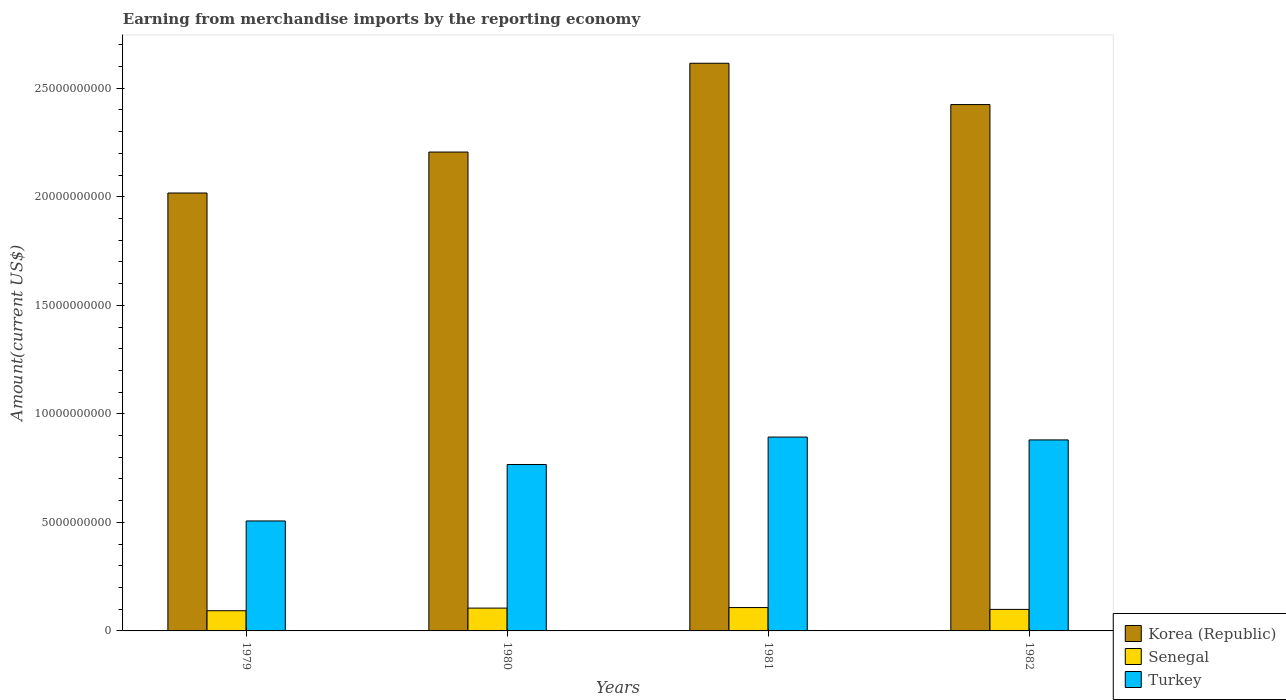Are the number of bars on each tick of the X-axis equal?
Your answer should be very brief. Yes. How many bars are there on the 1st tick from the left?
Provide a short and direct response. 3. What is the label of the 3rd group of bars from the left?
Your answer should be compact. 1981. What is the amount earned from merchandise imports in Turkey in 1982?
Offer a very short reply. 8.80e+09. Across all years, what is the maximum amount earned from merchandise imports in Korea (Republic)?
Your answer should be very brief. 2.62e+1. Across all years, what is the minimum amount earned from merchandise imports in Turkey?
Keep it short and to the point. 5.07e+09. In which year was the amount earned from merchandise imports in Korea (Republic) minimum?
Offer a terse response. 1979. What is the total amount earned from merchandise imports in Korea (Republic) in the graph?
Your response must be concise. 9.26e+1. What is the difference between the amount earned from merchandise imports in Turkey in 1980 and that in 1981?
Give a very brief answer. -1.26e+09. What is the difference between the amount earned from merchandise imports in Senegal in 1981 and the amount earned from merchandise imports in Korea (Republic) in 1980?
Provide a short and direct response. -2.10e+1. What is the average amount earned from merchandise imports in Korea (Republic) per year?
Make the answer very short. 2.32e+1. In the year 1980, what is the difference between the amount earned from merchandise imports in Turkey and amount earned from merchandise imports in Senegal?
Provide a succinct answer. 6.62e+09. In how many years, is the amount earned from merchandise imports in Turkey greater than 23000000000 US$?
Make the answer very short. 0. What is the ratio of the amount earned from merchandise imports in Turkey in 1981 to that in 1982?
Your answer should be compact. 1.01. Is the amount earned from merchandise imports in Senegal in 1980 less than that in 1982?
Offer a very short reply. No. Is the difference between the amount earned from merchandise imports in Turkey in 1979 and 1980 greater than the difference between the amount earned from merchandise imports in Senegal in 1979 and 1980?
Ensure brevity in your answer.  No. What is the difference between the highest and the second highest amount earned from merchandise imports in Turkey?
Provide a short and direct response. 1.31e+08. What is the difference between the highest and the lowest amount earned from merchandise imports in Turkey?
Ensure brevity in your answer.  3.87e+09. In how many years, is the amount earned from merchandise imports in Turkey greater than the average amount earned from merchandise imports in Turkey taken over all years?
Your answer should be compact. 3. What does the 3rd bar from the left in 1982 represents?
Your response must be concise. Turkey. What does the 2nd bar from the right in 1980 represents?
Offer a very short reply. Senegal. How many bars are there?
Provide a short and direct response. 12. How many years are there in the graph?
Offer a very short reply. 4. What is the difference between two consecutive major ticks on the Y-axis?
Offer a very short reply. 5.00e+09. Does the graph contain any zero values?
Make the answer very short. No. Does the graph contain grids?
Give a very brief answer. No. Where does the legend appear in the graph?
Make the answer very short. Bottom right. What is the title of the graph?
Keep it short and to the point. Earning from merchandise imports by the reporting economy. What is the label or title of the X-axis?
Offer a terse response. Years. What is the label or title of the Y-axis?
Give a very brief answer. Amount(current US$). What is the Amount(current US$) in Korea (Republic) in 1979?
Provide a succinct answer. 2.02e+1. What is the Amount(current US$) of Senegal in 1979?
Offer a terse response. 9.31e+08. What is the Amount(current US$) in Turkey in 1979?
Your answer should be compact. 5.07e+09. What is the Amount(current US$) of Korea (Republic) in 1980?
Provide a short and direct response. 2.21e+1. What is the Amount(current US$) in Senegal in 1980?
Offer a very short reply. 1.05e+09. What is the Amount(current US$) in Turkey in 1980?
Offer a terse response. 7.67e+09. What is the Amount(current US$) in Korea (Republic) in 1981?
Keep it short and to the point. 2.62e+1. What is the Amount(current US$) of Senegal in 1981?
Offer a very short reply. 1.08e+09. What is the Amount(current US$) of Turkey in 1981?
Offer a very short reply. 8.93e+09. What is the Amount(current US$) in Korea (Republic) in 1982?
Ensure brevity in your answer.  2.43e+1. What is the Amount(current US$) in Senegal in 1982?
Your answer should be compact. 9.92e+08. What is the Amount(current US$) of Turkey in 1982?
Provide a succinct answer. 8.80e+09. Across all years, what is the maximum Amount(current US$) in Korea (Republic)?
Give a very brief answer. 2.62e+1. Across all years, what is the maximum Amount(current US$) of Senegal?
Offer a very short reply. 1.08e+09. Across all years, what is the maximum Amount(current US$) of Turkey?
Offer a very short reply. 8.93e+09. Across all years, what is the minimum Amount(current US$) in Korea (Republic)?
Offer a very short reply. 2.02e+1. Across all years, what is the minimum Amount(current US$) of Senegal?
Offer a very short reply. 9.31e+08. Across all years, what is the minimum Amount(current US$) in Turkey?
Your response must be concise. 5.07e+09. What is the total Amount(current US$) in Korea (Republic) in the graph?
Your answer should be very brief. 9.26e+1. What is the total Amount(current US$) of Senegal in the graph?
Provide a succinct answer. 4.05e+09. What is the total Amount(current US$) of Turkey in the graph?
Offer a terse response. 3.05e+1. What is the difference between the Amount(current US$) of Korea (Republic) in 1979 and that in 1980?
Ensure brevity in your answer.  -1.89e+09. What is the difference between the Amount(current US$) in Senegal in 1979 and that in 1980?
Provide a short and direct response. -1.21e+08. What is the difference between the Amount(current US$) of Turkey in 1979 and that in 1980?
Give a very brief answer. -2.60e+09. What is the difference between the Amount(current US$) in Korea (Republic) in 1979 and that in 1981?
Provide a short and direct response. -5.98e+09. What is the difference between the Amount(current US$) of Senegal in 1979 and that in 1981?
Keep it short and to the point. -1.45e+08. What is the difference between the Amount(current US$) in Turkey in 1979 and that in 1981?
Give a very brief answer. -3.87e+09. What is the difference between the Amount(current US$) of Korea (Republic) in 1979 and that in 1982?
Make the answer very short. -4.07e+09. What is the difference between the Amount(current US$) of Senegal in 1979 and that in 1982?
Offer a terse response. -6.11e+07. What is the difference between the Amount(current US$) of Turkey in 1979 and that in 1982?
Make the answer very short. -3.73e+09. What is the difference between the Amount(current US$) of Korea (Republic) in 1980 and that in 1981?
Keep it short and to the point. -4.09e+09. What is the difference between the Amount(current US$) in Senegal in 1980 and that in 1981?
Offer a terse response. -2.41e+07. What is the difference between the Amount(current US$) of Turkey in 1980 and that in 1981?
Offer a terse response. -1.26e+09. What is the difference between the Amount(current US$) of Korea (Republic) in 1980 and that in 1982?
Offer a very short reply. -2.19e+09. What is the difference between the Amount(current US$) in Senegal in 1980 and that in 1982?
Provide a succinct answer. 5.99e+07. What is the difference between the Amount(current US$) of Turkey in 1980 and that in 1982?
Offer a very short reply. -1.13e+09. What is the difference between the Amount(current US$) of Korea (Republic) in 1981 and that in 1982?
Provide a short and direct response. 1.90e+09. What is the difference between the Amount(current US$) of Senegal in 1981 and that in 1982?
Your answer should be very brief. 8.40e+07. What is the difference between the Amount(current US$) in Turkey in 1981 and that in 1982?
Your answer should be very brief. 1.31e+08. What is the difference between the Amount(current US$) in Korea (Republic) in 1979 and the Amount(current US$) in Senegal in 1980?
Make the answer very short. 1.91e+1. What is the difference between the Amount(current US$) of Korea (Republic) in 1979 and the Amount(current US$) of Turkey in 1980?
Ensure brevity in your answer.  1.25e+1. What is the difference between the Amount(current US$) in Senegal in 1979 and the Amount(current US$) in Turkey in 1980?
Offer a terse response. -6.74e+09. What is the difference between the Amount(current US$) in Korea (Republic) in 1979 and the Amount(current US$) in Senegal in 1981?
Provide a succinct answer. 1.91e+1. What is the difference between the Amount(current US$) in Korea (Republic) in 1979 and the Amount(current US$) in Turkey in 1981?
Provide a succinct answer. 1.12e+1. What is the difference between the Amount(current US$) of Senegal in 1979 and the Amount(current US$) of Turkey in 1981?
Your response must be concise. -8.00e+09. What is the difference between the Amount(current US$) of Korea (Republic) in 1979 and the Amount(current US$) of Senegal in 1982?
Your answer should be compact. 1.92e+1. What is the difference between the Amount(current US$) of Korea (Republic) in 1979 and the Amount(current US$) of Turkey in 1982?
Your response must be concise. 1.14e+1. What is the difference between the Amount(current US$) in Senegal in 1979 and the Amount(current US$) in Turkey in 1982?
Offer a very short reply. -7.87e+09. What is the difference between the Amount(current US$) of Korea (Republic) in 1980 and the Amount(current US$) of Senegal in 1981?
Your response must be concise. 2.10e+1. What is the difference between the Amount(current US$) of Korea (Republic) in 1980 and the Amount(current US$) of Turkey in 1981?
Keep it short and to the point. 1.31e+1. What is the difference between the Amount(current US$) of Senegal in 1980 and the Amount(current US$) of Turkey in 1981?
Your response must be concise. -7.88e+09. What is the difference between the Amount(current US$) of Korea (Republic) in 1980 and the Amount(current US$) of Senegal in 1982?
Make the answer very short. 2.11e+1. What is the difference between the Amount(current US$) of Korea (Republic) in 1980 and the Amount(current US$) of Turkey in 1982?
Your response must be concise. 1.33e+1. What is the difference between the Amount(current US$) of Senegal in 1980 and the Amount(current US$) of Turkey in 1982?
Your response must be concise. -7.75e+09. What is the difference between the Amount(current US$) of Korea (Republic) in 1981 and the Amount(current US$) of Senegal in 1982?
Keep it short and to the point. 2.52e+1. What is the difference between the Amount(current US$) in Korea (Republic) in 1981 and the Amount(current US$) in Turkey in 1982?
Your answer should be compact. 1.74e+1. What is the difference between the Amount(current US$) in Senegal in 1981 and the Amount(current US$) in Turkey in 1982?
Provide a succinct answer. -7.72e+09. What is the average Amount(current US$) of Korea (Republic) per year?
Offer a very short reply. 2.32e+1. What is the average Amount(current US$) in Senegal per year?
Make the answer very short. 1.01e+09. What is the average Amount(current US$) in Turkey per year?
Provide a short and direct response. 7.62e+09. In the year 1979, what is the difference between the Amount(current US$) in Korea (Republic) and Amount(current US$) in Senegal?
Keep it short and to the point. 1.92e+1. In the year 1979, what is the difference between the Amount(current US$) in Korea (Republic) and Amount(current US$) in Turkey?
Provide a succinct answer. 1.51e+1. In the year 1979, what is the difference between the Amount(current US$) in Senegal and Amount(current US$) in Turkey?
Your answer should be very brief. -4.14e+09. In the year 1980, what is the difference between the Amount(current US$) of Korea (Republic) and Amount(current US$) of Senegal?
Make the answer very short. 2.10e+1. In the year 1980, what is the difference between the Amount(current US$) in Korea (Republic) and Amount(current US$) in Turkey?
Give a very brief answer. 1.44e+1. In the year 1980, what is the difference between the Amount(current US$) in Senegal and Amount(current US$) in Turkey?
Provide a short and direct response. -6.62e+09. In the year 1981, what is the difference between the Amount(current US$) of Korea (Republic) and Amount(current US$) of Senegal?
Your answer should be very brief. 2.51e+1. In the year 1981, what is the difference between the Amount(current US$) of Korea (Republic) and Amount(current US$) of Turkey?
Give a very brief answer. 1.72e+1. In the year 1981, what is the difference between the Amount(current US$) in Senegal and Amount(current US$) in Turkey?
Ensure brevity in your answer.  -7.86e+09. In the year 1982, what is the difference between the Amount(current US$) in Korea (Republic) and Amount(current US$) in Senegal?
Keep it short and to the point. 2.33e+1. In the year 1982, what is the difference between the Amount(current US$) of Korea (Republic) and Amount(current US$) of Turkey?
Ensure brevity in your answer.  1.54e+1. In the year 1982, what is the difference between the Amount(current US$) of Senegal and Amount(current US$) of Turkey?
Provide a short and direct response. -7.81e+09. What is the ratio of the Amount(current US$) in Korea (Republic) in 1979 to that in 1980?
Your answer should be very brief. 0.91. What is the ratio of the Amount(current US$) of Senegal in 1979 to that in 1980?
Ensure brevity in your answer.  0.89. What is the ratio of the Amount(current US$) of Turkey in 1979 to that in 1980?
Your response must be concise. 0.66. What is the ratio of the Amount(current US$) in Korea (Republic) in 1979 to that in 1981?
Give a very brief answer. 0.77. What is the ratio of the Amount(current US$) of Senegal in 1979 to that in 1981?
Keep it short and to the point. 0.87. What is the ratio of the Amount(current US$) in Turkey in 1979 to that in 1981?
Your response must be concise. 0.57. What is the ratio of the Amount(current US$) in Korea (Republic) in 1979 to that in 1982?
Keep it short and to the point. 0.83. What is the ratio of the Amount(current US$) of Senegal in 1979 to that in 1982?
Make the answer very short. 0.94. What is the ratio of the Amount(current US$) in Turkey in 1979 to that in 1982?
Your answer should be compact. 0.58. What is the ratio of the Amount(current US$) in Korea (Republic) in 1980 to that in 1981?
Your response must be concise. 0.84. What is the ratio of the Amount(current US$) in Senegal in 1980 to that in 1981?
Provide a short and direct response. 0.98. What is the ratio of the Amount(current US$) of Turkey in 1980 to that in 1981?
Give a very brief answer. 0.86. What is the ratio of the Amount(current US$) of Korea (Republic) in 1980 to that in 1982?
Your response must be concise. 0.91. What is the ratio of the Amount(current US$) of Senegal in 1980 to that in 1982?
Your response must be concise. 1.06. What is the ratio of the Amount(current US$) in Turkey in 1980 to that in 1982?
Give a very brief answer. 0.87. What is the ratio of the Amount(current US$) in Korea (Republic) in 1981 to that in 1982?
Keep it short and to the point. 1.08. What is the ratio of the Amount(current US$) of Senegal in 1981 to that in 1982?
Your answer should be very brief. 1.08. What is the ratio of the Amount(current US$) in Turkey in 1981 to that in 1982?
Keep it short and to the point. 1.01. What is the difference between the highest and the second highest Amount(current US$) of Korea (Republic)?
Give a very brief answer. 1.90e+09. What is the difference between the highest and the second highest Amount(current US$) in Senegal?
Give a very brief answer. 2.41e+07. What is the difference between the highest and the second highest Amount(current US$) in Turkey?
Your response must be concise. 1.31e+08. What is the difference between the highest and the lowest Amount(current US$) in Korea (Republic)?
Offer a terse response. 5.98e+09. What is the difference between the highest and the lowest Amount(current US$) of Senegal?
Provide a succinct answer. 1.45e+08. What is the difference between the highest and the lowest Amount(current US$) in Turkey?
Your answer should be compact. 3.87e+09. 